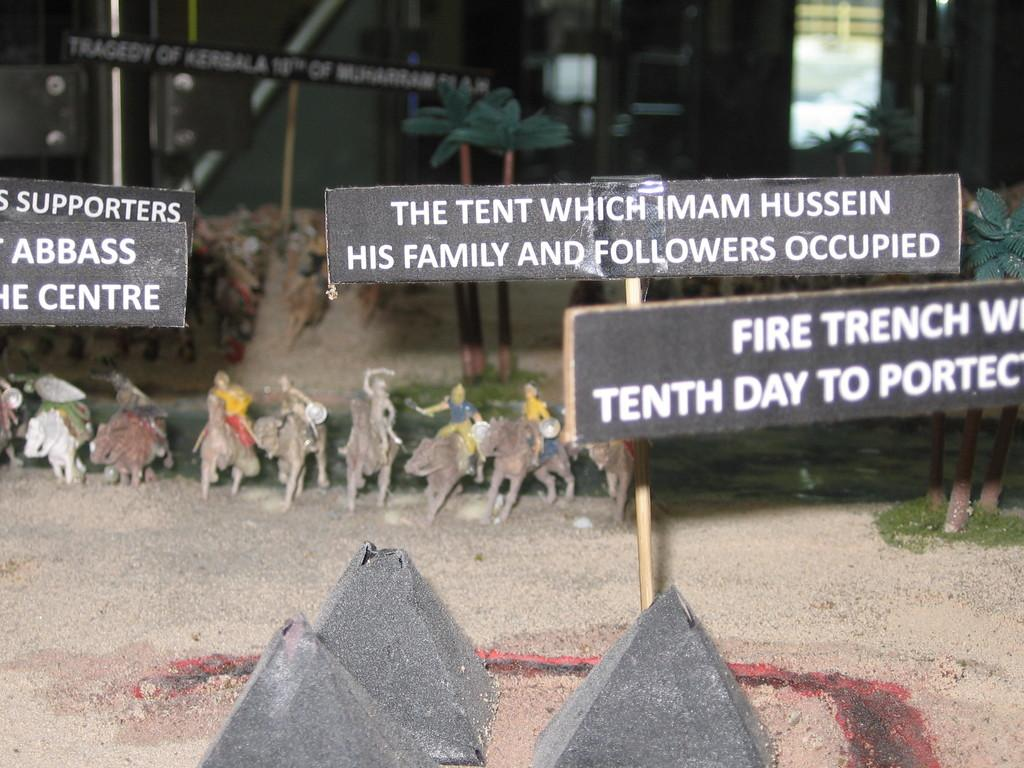What type of objects can be seen in the image? There are boards, toys, pyramids, and a door in the image. What natural elements are present in the image? Trees, soil, and grass are present in the image. What type of structure can be seen in the image? There is a wall in the image. What type of bread is being used to make an agreement in the image? There is no bread or agreement present in the image. How does the wall help the trees in the image? The wall does not help the trees in the image; it is a separate structure. 